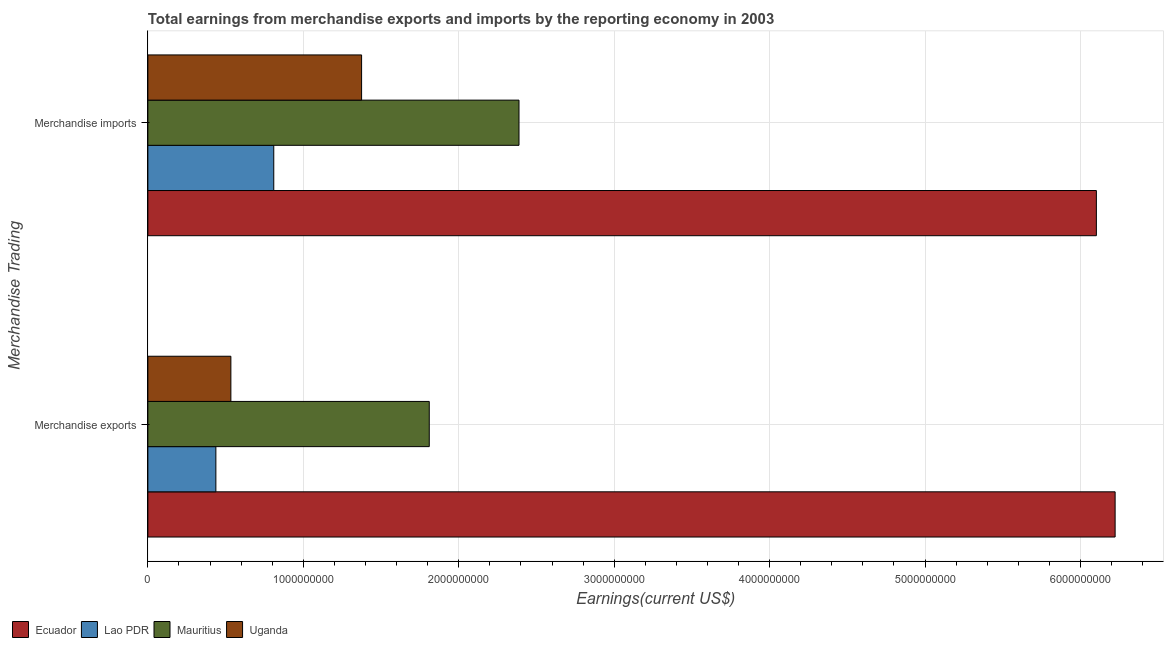How many different coloured bars are there?
Ensure brevity in your answer.  4. Are the number of bars per tick equal to the number of legend labels?
Offer a terse response. Yes. Are the number of bars on each tick of the Y-axis equal?
Make the answer very short. Yes. What is the label of the 1st group of bars from the top?
Your answer should be compact. Merchandise imports. What is the earnings from merchandise imports in Uganda?
Give a very brief answer. 1.37e+09. Across all countries, what is the maximum earnings from merchandise imports?
Your answer should be very brief. 6.10e+09. Across all countries, what is the minimum earnings from merchandise imports?
Your response must be concise. 8.10e+08. In which country was the earnings from merchandise imports maximum?
Give a very brief answer. Ecuador. In which country was the earnings from merchandise imports minimum?
Ensure brevity in your answer.  Lao PDR. What is the total earnings from merchandise imports in the graph?
Your answer should be very brief. 1.07e+1. What is the difference between the earnings from merchandise exports in Mauritius and that in Uganda?
Your answer should be compact. 1.28e+09. What is the difference between the earnings from merchandise imports in Lao PDR and the earnings from merchandise exports in Ecuador?
Offer a very short reply. -5.41e+09. What is the average earnings from merchandise imports per country?
Give a very brief answer. 2.67e+09. What is the difference between the earnings from merchandise exports and earnings from merchandise imports in Mauritius?
Your answer should be very brief. -5.77e+08. What is the ratio of the earnings from merchandise imports in Uganda to that in Lao PDR?
Offer a terse response. 1.7. In how many countries, is the earnings from merchandise exports greater than the average earnings from merchandise exports taken over all countries?
Your answer should be compact. 1. What does the 2nd bar from the top in Merchandise exports represents?
Your response must be concise. Mauritius. What does the 1st bar from the bottom in Merchandise exports represents?
Give a very brief answer. Ecuador. How many bars are there?
Ensure brevity in your answer.  8. Are the values on the major ticks of X-axis written in scientific E-notation?
Offer a terse response. No. Does the graph contain any zero values?
Provide a succinct answer. No. Where does the legend appear in the graph?
Offer a very short reply. Bottom left. How are the legend labels stacked?
Ensure brevity in your answer.  Horizontal. What is the title of the graph?
Provide a short and direct response. Total earnings from merchandise exports and imports by the reporting economy in 2003. What is the label or title of the X-axis?
Offer a very short reply. Earnings(current US$). What is the label or title of the Y-axis?
Provide a short and direct response. Merchandise Trading. What is the Earnings(current US$) of Ecuador in Merchandise exports?
Provide a succinct answer. 6.22e+09. What is the Earnings(current US$) in Lao PDR in Merchandise exports?
Provide a short and direct response. 4.38e+08. What is the Earnings(current US$) in Mauritius in Merchandise exports?
Ensure brevity in your answer.  1.81e+09. What is the Earnings(current US$) in Uganda in Merchandise exports?
Provide a succinct answer. 5.34e+08. What is the Earnings(current US$) of Ecuador in Merchandise imports?
Make the answer very short. 6.10e+09. What is the Earnings(current US$) in Lao PDR in Merchandise imports?
Your answer should be compact. 8.10e+08. What is the Earnings(current US$) of Mauritius in Merchandise imports?
Your response must be concise. 2.39e+09. What is the Earnings(current US$) in Uganda in Merchandise imports?
Offer a terse response. 1.37e+09. Across all Merchandise Trading, what is the maximum Earnings(current US$) of Ecuador?
Provide a short and direct response. 6.22e+09. Across all Merchandise Trading, what is the maximum Earnings(current US$) in Lao PDR?
Ensure brevity in your answer.  8.10e+08. Across all Merchandise Trading, what is the maximum Earnings(current US$) in Mauritius?
Offer a very short reply. 2.39e+09. Across all Merchandise Trading, what is the maximum Earnings(current US$) of Uganda?
Your answer should be very brief. 1.37e+09. Across all Merchandise Trading, what is the minimum Earnings(current US$) of Ecuador?
Your answer should be very brief. 6.10e+09. Across all Merchandise Trading, what is the minimum Earnings(current US$) of Lao PDR?
Your response must be concise. 4.38e+08. Across all Merchandise Trading, what is the minimum Earnings(current US$) of Mauritius?
Offer a very short reply. 1.81e+09. Across all Merchandise Trading, what is the minimum Earnings(current US$) in Uganda?
Give a very brief answer. 5.34e+08. What is the total Earnings(current US$) of Ecuador in the graph?
Provide a succinct answer. 1.23e+1. What is the total Earnings(current US$) in Lao PDR in the graph?
Ensure brevity in your answer.  1.25e+09. What is the total Earnings(current US$) in Mauritius in the graph?
Keep it short and to the point. 4.20e+09. What is the total Earnings(current US$) in Uganda in the graph?
Provide a succinct answer. 1.91e+09. What is the difference between the Earnings(current US$) in Ecuador in Merchandise exports and that in Merchandise imports?
Your answer should be very brief. 1.21e+08. What is the difference between the Earnings(current US$) of Lao PDR in Merchandise exports and that in Merchandise imports?
Offer a very short reply. -3.72e+08. What is the difference between the Earnings(current US$) of Mauritius in Merchandise exports and that in Merchandise imports?
Offer a terse response. -5.77e+08. What is the difference between the Earnings(current US$) of Uganda in Merchandise exports and that in Merchandise imports?
Your answer should be very brief. -8.41e+08. What is the difference between the Earnings(current US$) in Ecuador in Merchandise exports and the Earnings(current US$) in Lao PDR in Merchandise imports?
Provide a succinct answer. 5.41e+09. What is the difference between the Earnings(current US$) of Ecuador in Merchandise exports and the Earnings(current US$) of Mauritius in Merchandise imports?
Your response must be concise. 3.84e+09. What is the difference between the Earnings(current US$) in Ecuador in Merchandise exports and the Earnings(current US$) in Uganda in Merchandise imports?
Keep it short and to the point. 4.85e+09. What is the difference between the Earnings(current US$) of Lao PDR in Merchandise exports and the Earnings(current US$) of Mauritius in Merchandise imports?
Your answer should be very brief. -1.95e+09. What is the difference between the Earnings(current US$) of Lao PDR in Merchandise exports and the Earnings(current US$) of Uganda in Merchandise imports?
Keep it short and to the point. -9.37e+08. What is the difference between the Earnings(current US$) of Mauritius in Merchandise exports and the Earnings(current US$) of Uganda in Merchandise imports?
Your answer should be very brief. 4.35e+08. What is the average Earnings(current US$) in Ecuador per Merchandise Trading?
Offer a terse response. 6.16e+09. What is the average Earnings(current US$) of Lao PDR per Merchandise Trading?
Keep it short and to the point. 6.24e+08. What is the average Earnings(current US$) of Mauritius per Merchandise Trading?
Your response must be concise. 2.10e+09. What is the average Earnings(current US$) of Uganda per Merchandise Trading?
Provide a short and direct response. 9.54e+08. What is the difference between the Earnings(current US$) of Ecuador and Earnings(current US$) of Lao PDR in Merchandise exports?
Make the answer very short. 5.79e+09. What is the difference between the Earnings(current US$) of Ecuador and Earnings(current US$) of Mauritius in Merchandise exports?
Make the answer very short. 4.41e+09. What is the difference between the Earnings(current US$) in Ecuador and Earnings(current US$) in Uganda in Merchandise exports?
Make the answer very short. 5.69e+09. What is the difference between the Earnings(current US$) in Lao PDR and Earnings(current US$) in Mauritius in Merchandise exports?
Provide a succinct answer. -1.37e+09. What is the difference between the Earnings(current US$) in Lao PDR and Earnings(current US$) in Uganda in Merchandise exports?
Your response must be concise. -9.65e+07. What is the difference between the Earnings(current US$) in Mauritius and Earnings(current US$) in Uganda in Merchandise exports?
Make the answer very short. 1.28e+09. What is the difference between the Earnings(current US$) of Ecuador and Earnings(current US$) of Lao PDR in Merchandise imports?
Your response must be concise. 5.29e+09. What is the difference between the Earnings(current US$) in Ecuador and Earnings(current US$) in Mauritius in Merchandise imports?
Your answer should be very brief. 3.71e+09. What is the difference between the Earnings(current US$) of Ecuador and Earnings(current US$) of Uganda in Merchandise imports?
Your answer should be very brief. 4.73e+09. What is the difference between the Earnings(current US$) of Lao PDR and Earnings(current US$) of Mauritius in Merchandise imports?
Provide a succinct answer. -1.58e+09. What is the difference between the Earnings(current US$) of Lao PDR and Earnings(current US$) of Uganda in Merchandise imports?
Ensure brevity in your answer.  -5.65e+08. What is the difference between the Earnings(current US$) in Mauritius and Earnings(current US$) in Uganda in Merchandise imports?
Your response must be concise. 1.01e+09. What is the ratio of the Earnings(current US$) in Ecuador in Merchandise exports to that in Merchandise imports?
Offer a terse response. 1.02. What is the ratio of the Earnings(current US$) in Lao PDR in Merchandise exports to that in Merchandise imports?
Offer a terse response. 0.54. What is the ratio of the Earnings(current US$) in Mauritius in Merchandise exports to that in Merchandise imports?
Make the answer very short. 0.76. What is the ratio of the Earnings(current US$) of Uganda in Merchandise exports to that in Merchandise imports?
Provide a succinct answer. 0.39. What is the difference between the highest and the second highest Earnings(current US$) in Ecuador?
Your answer should be compact. 1.21e+08. What is the difference between the highest and the second highest Earnings(current US$) of Lao PDR?
Your answer should be very brief. 3.72e+08. What is the difference between the highest and the second highest Earnings(current US$) of Mauritius?
Give a very brief answer. 5.77e+08. What is the difference between the highest and the second highest Earnings(current US$) of Uganda?
Give a very brief answer. 8.41e+08. What is the difference between the highest and the lowest Earnings(current US$) of Ecuador?
Provide a succinct answer. 1.21e+08. What is the difference between the highest and the lowest Earnings(current US$) of Lao PDR?
Your answer should be compact. 3.72e+08. What is the difference between the highest and the lowest Earnings(current US$) in Mauritius?
Offer a very short reply. 5.77e+08. What is the difference between the highest and the lowest Earnings(current US$) of Uganda?
Your answer should be compact. 8.41e+08. 